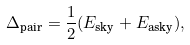<formula> <loc_0><loc_0><loc_500><loc_500>\Delta _ { \text {pair} } = \frac { 1 } { 2 } ( E _ { \text {sky} } + E _ { \text {asky} } ) ,</formula> 